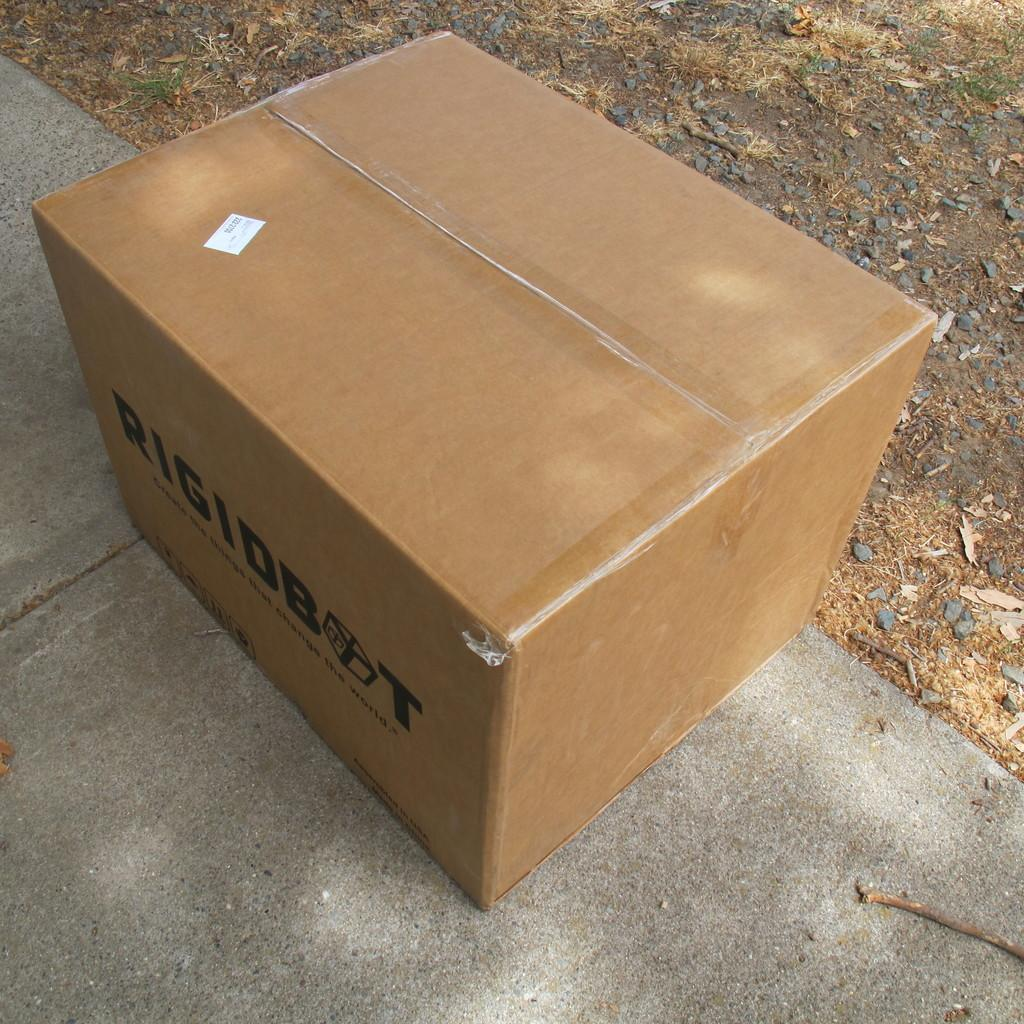What is on the ground in the image? There is a box on the ground, as well as a stick, stones, and leaves. How is the box wrapped? The box is wrapped with plaster. Is there any additional information on the box? Yes, there is a sticker pasted on the box and text written on it. What is the purpose of the stick on the ground? The purpose of the stick on the ground is not clear from the image. What type of pen is used to write on the box in the image? There is no pen visible in the image, and the text on the box could have been written using various tools. 